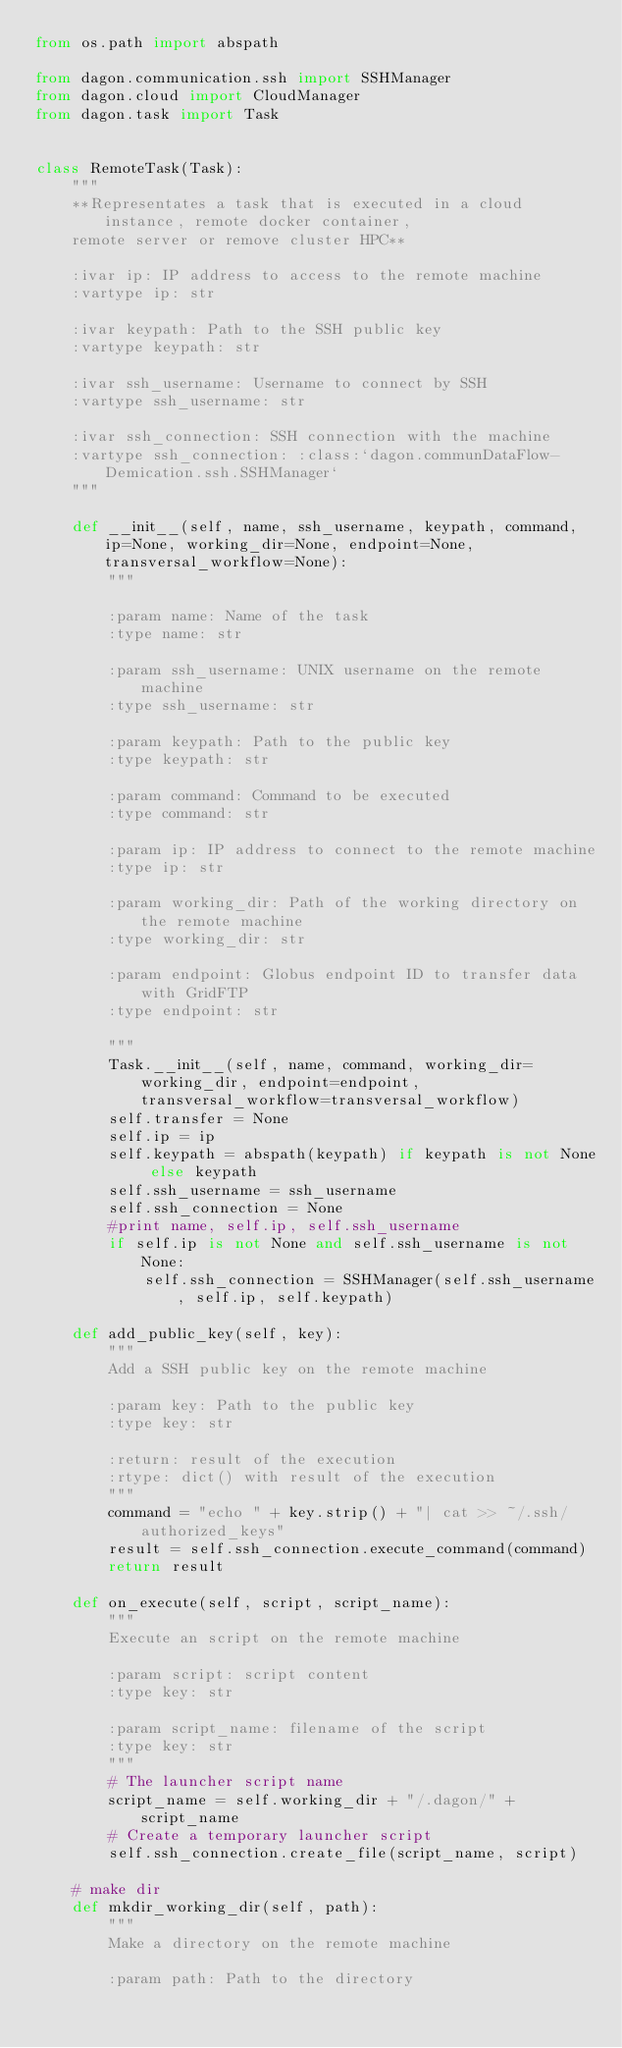Convert code to text. <code><loc_0><loc_0><loc_500><loc_500><_Python_>from os.path import abspath

from dagon.communication.ssh import SSHManager
from dagon.cloud import CloudManager
from dagon.task import Task


class RemoteTask(Task):
    """
    **Representates a task that is executed in a cloud instance, remote docker container,
    remote server or remove cluster HPC**

    :ivar ip: IP address to access to the remote machine
    :vartype ip: str

    :ivar keypath: Path to the SSH public key
    :vartype keypath: str

    :ivar ssh_username: Username to connect by SSH
    :vartype ssh_username: str

    :ivar ssh_connection: SSH connection with the machine
    :vartype ssh_connection: :class:`dagon.communDataFlow-Demication.ssh.SSHManager`
    """

    def __init__(self, name, ssh_username, keypath, command, ip=None, working_dir=None, endpoint=None,transversal_workflow=None):
        """

        :param name: Name of the task
        :type name: str

        :param ssh_username: UNIX username on the remote machine
        :type ssh_username: str

        :param keypath: Path to the public key
        :type keypath: str

        :param command: Command to be executed
        :type command: str

        :param ip: IP address to connect to the remote machine
        :type ip: str

        :param working_dir: Path of the working directory on the remote machine
        :type working_dir: str

        :param endpoint: Globus endpoint ID to transfer data with GridFTP
        :type endpoint: str

        """
        Task.__init__(self, name, command, working_dir=working_dir, endpoint=endpoint,transversal_workflow=transversal_workflow)
        self.transfer = None
        self.ip = ip
        self.keypath = abspath(keypath) if keypath is not None else keypath
        self.ssh_username = ssh_username
        self.ssh_connection = None
        #print name, self.ip, self.ssh_username
        if self.ip is not None and self.ssh_username is not None:
            self.ssh_connection = SSHManager(self.ssh_username, self.ip, self.keypath)

    def add_public_key(self, key):
        """
        Add a SSH public key on the remote machine

        :param key: Path to the public key
        :type key: str

        :return: result of the execution
        :rtype: dict() with result of the execution
        """
        command = "echo " + key.strip() + "| cat >> ~/.ssh/authorized_keys"
        result = self.ssh_connection.execute_command(command)
        return result

    def on_execute(self, script, script_name):
        """
        Execute an script on the remote machine

        :param script: script content
        :type key: str

        :param script_name: filename of the script
        :type key: str
        """
        # The launcher script name
        script_name = self.working_dir + "/.dagon/" + script_name
        # Create a temporary launcher script
        self.ssh_connection.create_file(script_name, script)

    # make dir
    def mkdir_working_dir(self, path):
        """
        Make a directory on the remote machine

        :param path: Path to the directory</code> 